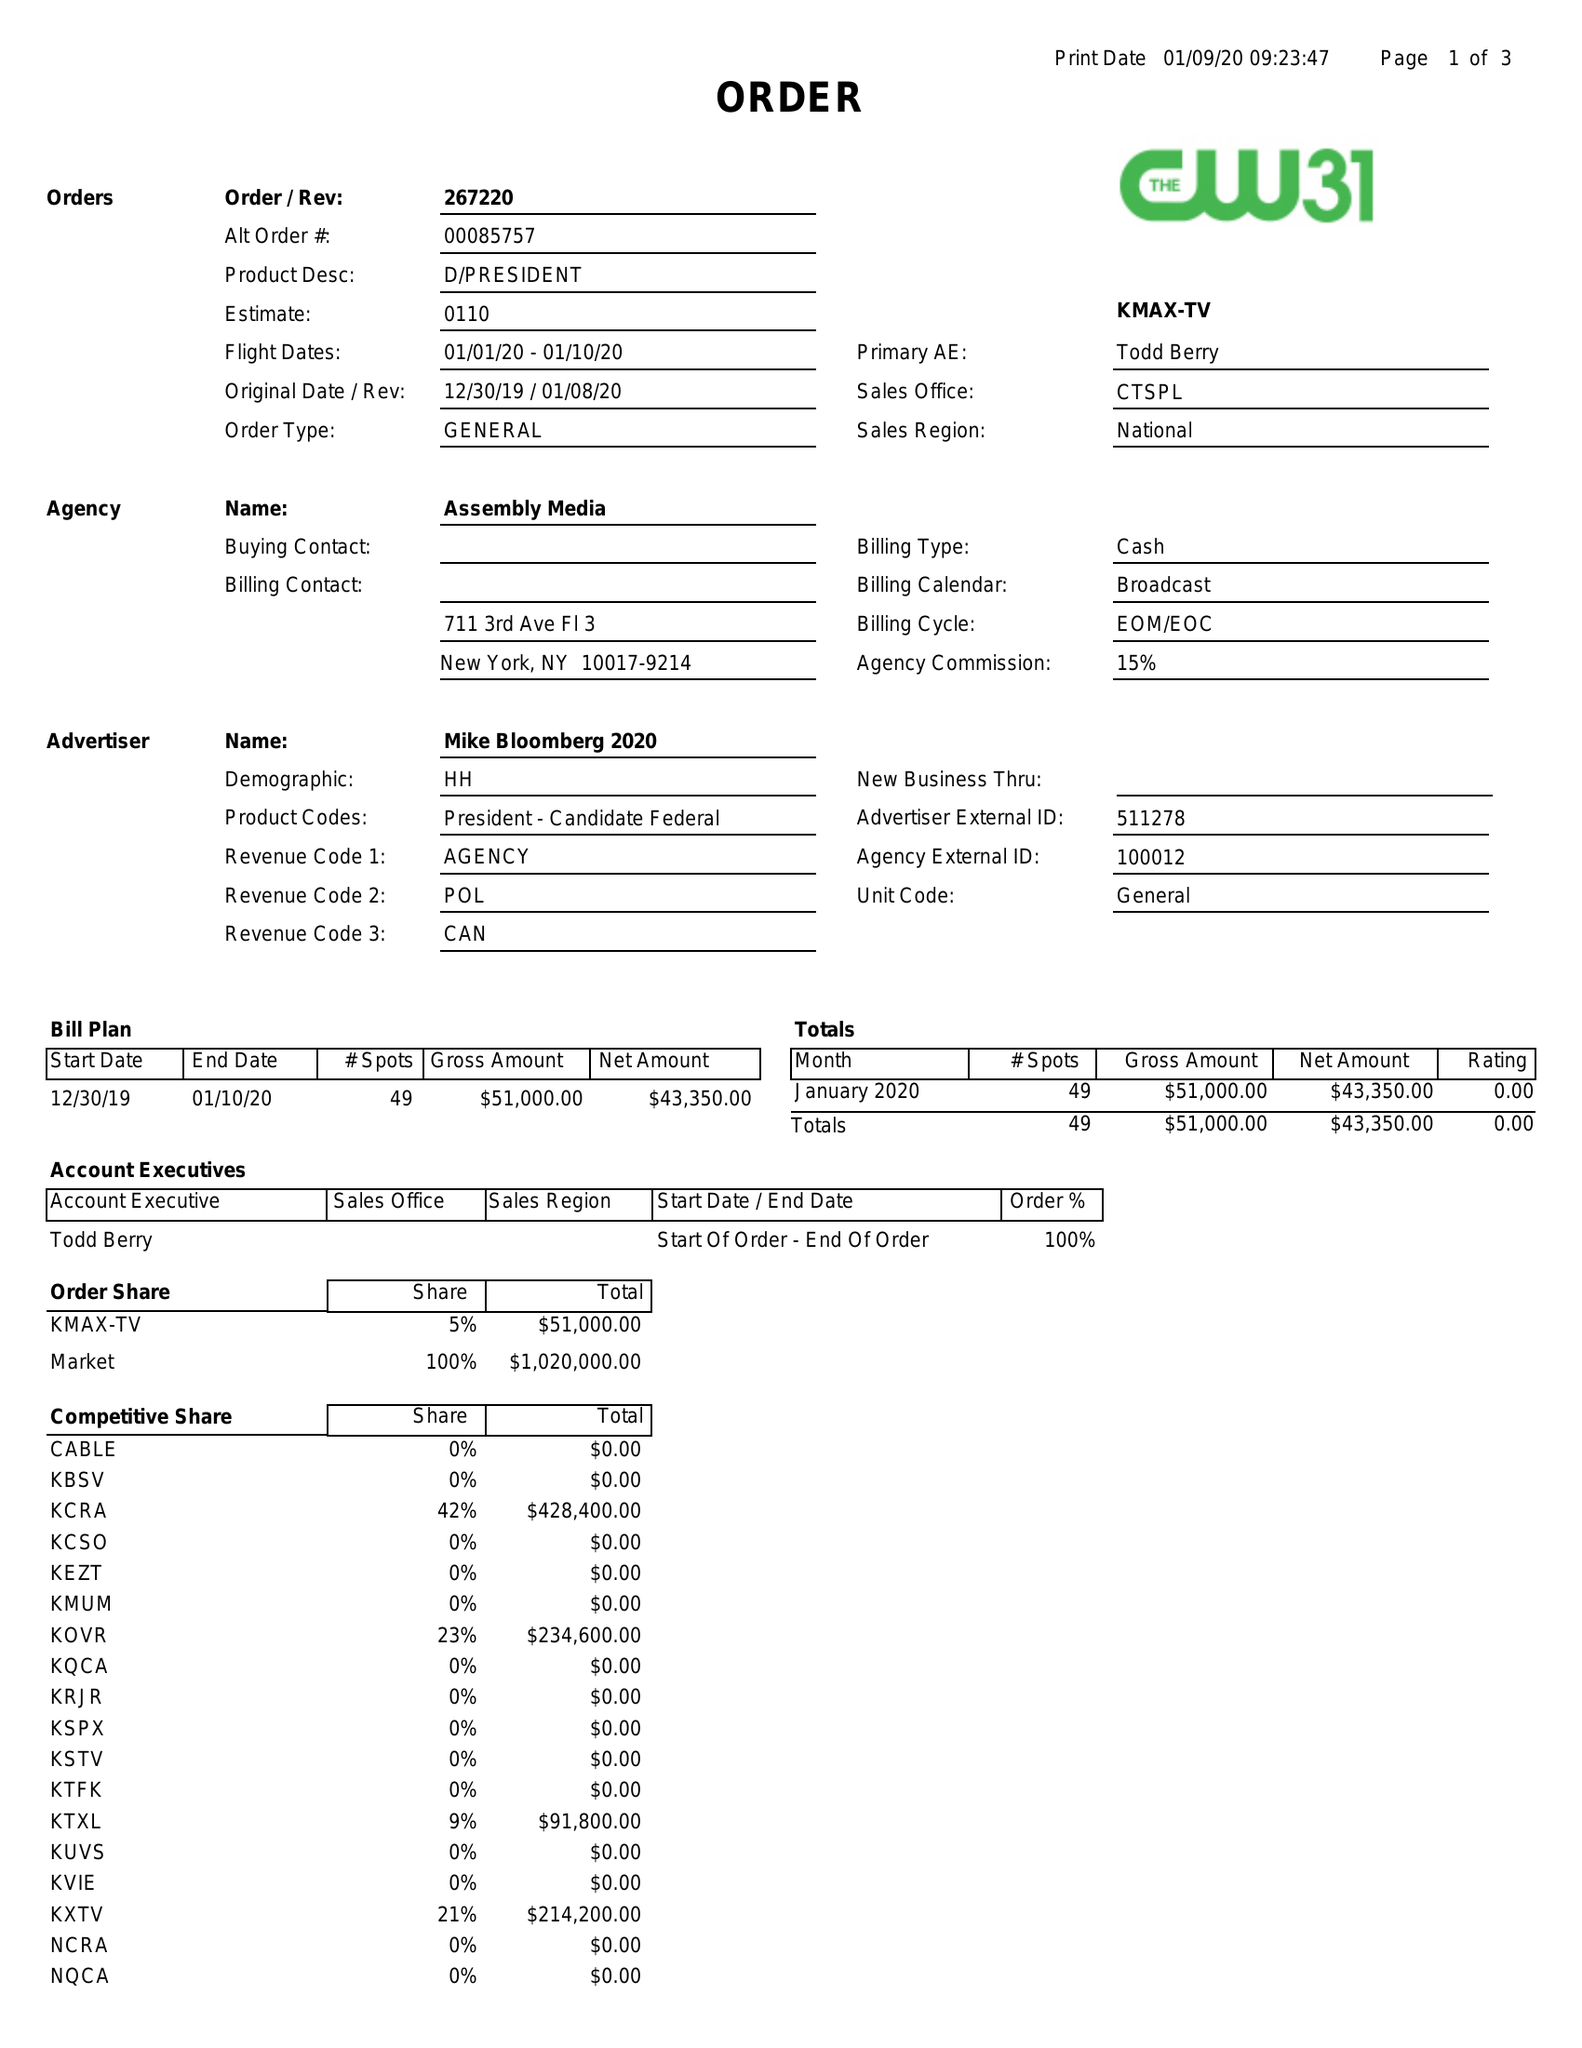What is the value for the gross_amount?
Answer the question using a single word or phrase. 51000.00 